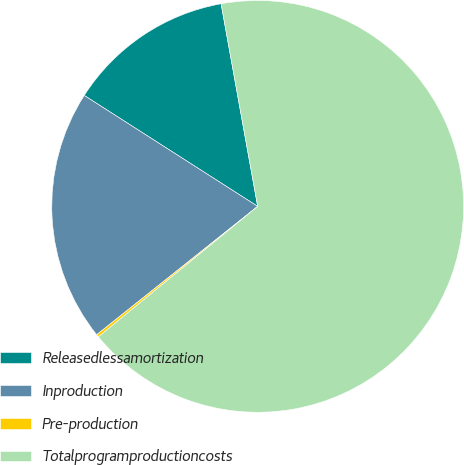Convert chart to OTSL. <chart><loc_0><loc_0><loc_500><loc_500><pie_chart><fcel>Releasedlessamortization<fcel>Inproduction<fcel>Pre-production<fcel>Totalprogramproductioncosts<nl><fcel>13.1%<fcel>19.77%<fcel>0.21%<fcel>66.92%<nl></chart> 